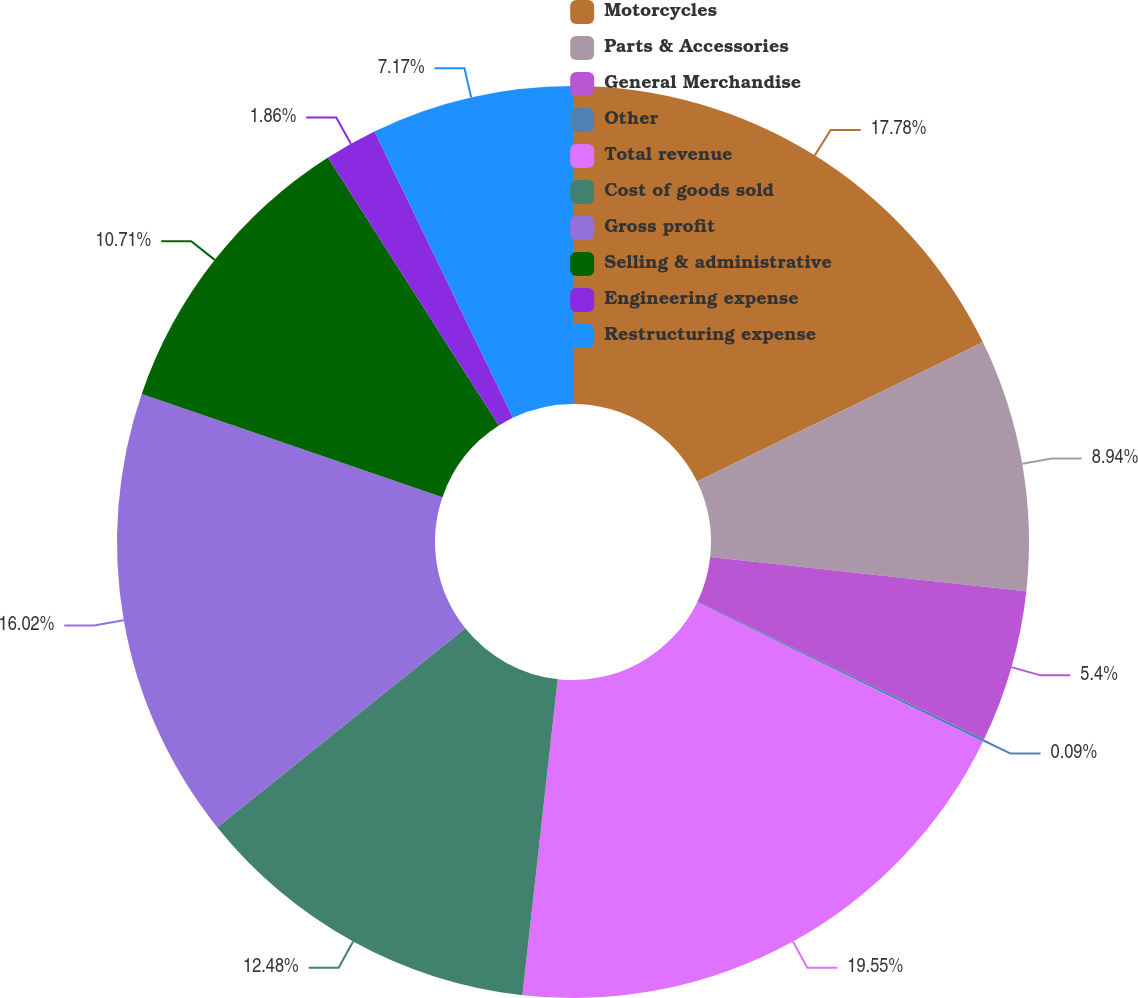Convert chart. <chart><loc_0><loc_0><loc_500><loc_500><pie_chart><fcel>Motorcycles<fcel>Parts & Accessories<fcel>General Merchandise<fcel>Other<fcel>Total revenue<fcel>Cost of goods sold<fcel>Gross profit<fcel>Selling & administrative<fcel>Engineering expense<fcel>Restructuring expense<nl><fcel>17.79%<fcel>8.94%<fcel>5.4%<fcel>0.09%<fcel>19.56%<fcel>12.48%<fcel>16.02%<fcel>10.71%<fcel>1.86%<fcel>7.17%<nl></chart> 